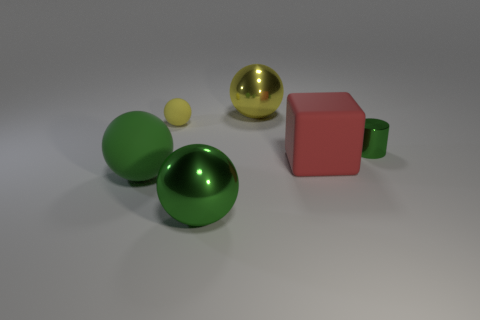What number of objects are green things to the right of the green rubber object or red objects?
Ensure brevity in your answer.  3. Do the metallic cylinder and the small ball have the same color?
Provide a short and direct response. No. How many other objects are there of the same shape as the big green matte thing?
Make the answer very short. 3. What number of yellow things are either large metal objects or big matte things?
Your answer should be compact. 1. What is the color of the big cube that is the same material as the small yellow sphere?
Your answer should be compact. Red. Are the green sphere left of the small sphere and the large green ball that is on the right side of the big green rubber sphere made of the same material?
Provide a succinct answer. No. The rubber object that is the same color as the small cylinder is what size?
Offer a terse response. Large. There is a green thing right of the big yellow ball; what is it made of?
Offer a terse response. Metal. There is a shiny object left of the yellow shiny sphere; is it the same shape as the yellow thing to the left of the big yellow shiny sphere?
Your answer should be very brief. Yes. There is a large object that is the same color as the big matte sphere; what is its material?
Keep it short and to the point. Metal. 